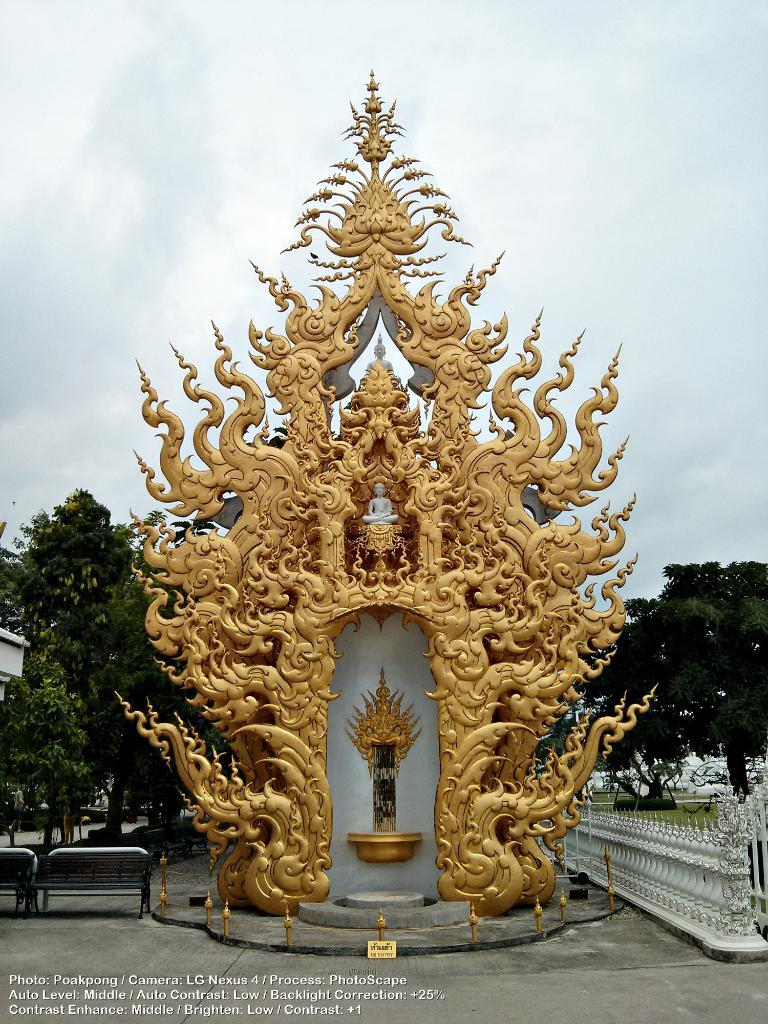What is the main subject in the image? There is a statue in the image. What can be seen around the statue? There are benches and a fence in the image. What is visible in the background of the image? Trees and the sky are visible in the background of the image. How does the sky appear in the image? The sky appears to be cloudy in the image. What is the tendency of the drawer in the image? There is no drawer present in the image. 